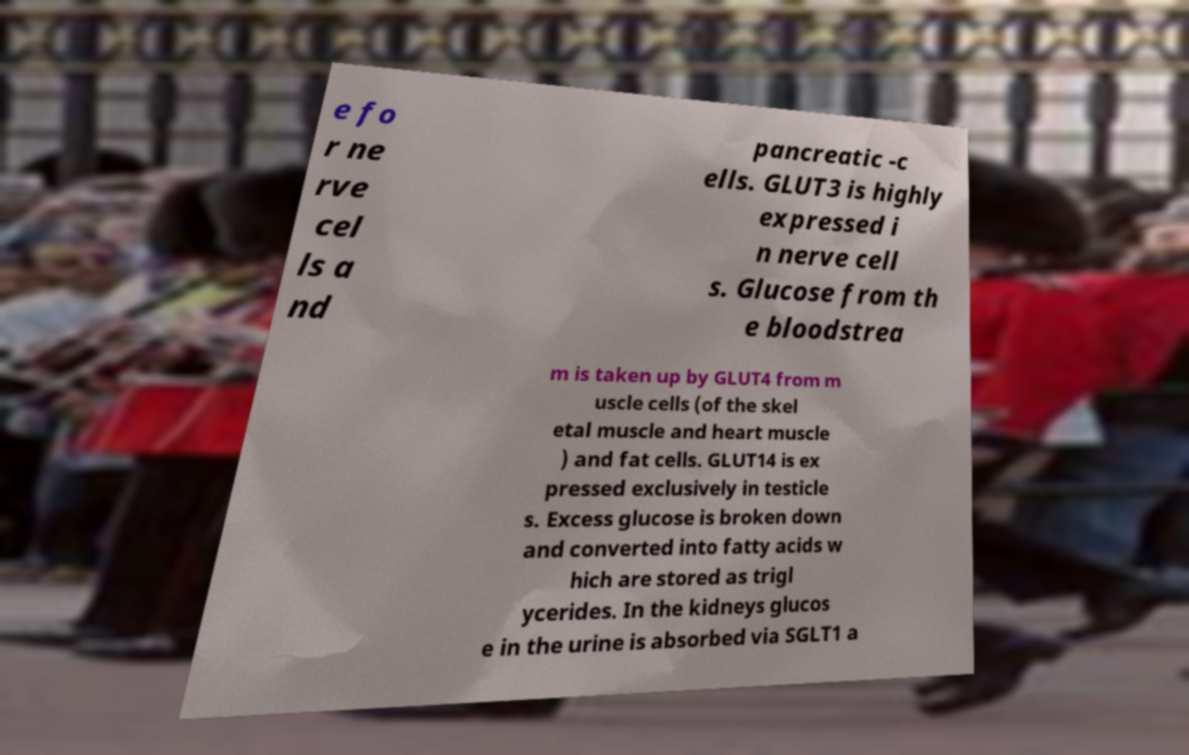I need the written content from this picture converted into text. Can you do that? e fo r ne rve cel ls a nd pancreatic -c ells. GLUT3 is highly expressed i n nerve cell s. Glucose from th e bloodstrea m is taken up by GLUT4 from m uscle cells (of the skel etal muscle and heart muscle ) and fat cells. GLUT14 is ex pressed exclusively in testicle s. Excess glucose is broken down and converted into fatty acids w hich are stored as trigl ycerides. In the kidneys glucos e in the urine is absorbed via SGLT1 a 